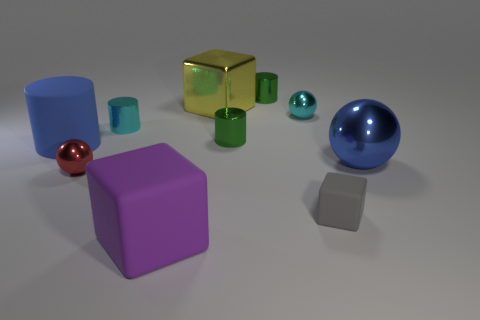Are the objects floating above the surface or resting on it? All objects appear to be resting on the surface. There are no shadows or other indications to suggest that any of the objects are floating. How can you tell that they are resting and not floating? You can determine that the objects are resting on the surface because each has a distinct contact shadow directly underneath it, consistent with the direction of the light source. 